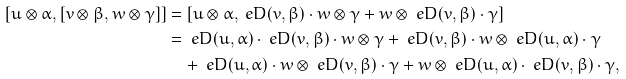Convert formula to latex. <formula><loc_0><loc_0><loc_500><loc_500>[ u \otimes \alpha , [ v \otimes \beta , w \otimes \gamma ] ] & = [ u \otimes \alpha , \ e D ( v , \beta ) \cdot w \otimes \gamma + w \otimes \ e D ( v , \beta ) \cdot \gamma ] \\ & = \ e D ( u , \alpha ) \cdot \ e D ( v , \beta ) \cdot w \otimes \gamma + \ e D ( v , \beta ) \cdot w \otimes \ e D ( u , \alpha ) \cdot \gamma \\ & \quad + \ e D ( u , \alpha ) \cdot w \otimes \ e D ( v , \beta ) \cdot \gamma + w \otimes \ e D ( u , \alpha ) \cdot \ e D ( v , \beta ) \cdot \gamma ,</formula> 